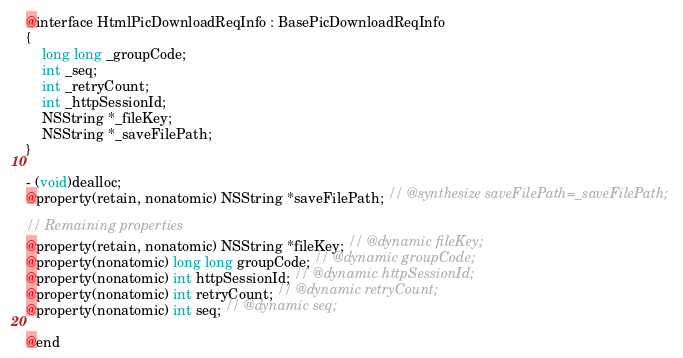<code> <loc_0><loc_0><loc_500><loc_500><_C_>
@interface HtmlPicDownloadReqInfo : BasePicDownloadReqInfo
{
    long long _groupCode;
    int _seq;
    int _retryCount;
    int _httpSessionId;
    NSString *_fileKey;
    NSString *_saveFilePath;
}

- (void)dealloc;
@property(retain, nonatomic) NSString *saveFilePath; // @synthesize saveFilePath=_saveFilePath;

// Remaining properties
@property(retain, nonatomic) NSString *fileKey; // @dynamic fileKey;
@property(nonatomic) long long groupCode; // @dynamic groupCode;
@property(nonatomic) int httpSessionId; // @dynamic httpSessionId;
@property(nonatomic) int retryCount; // @dynamic retryCount;
@property(nonatomic) int seq; // @dynamic seq;

@end

</code> 